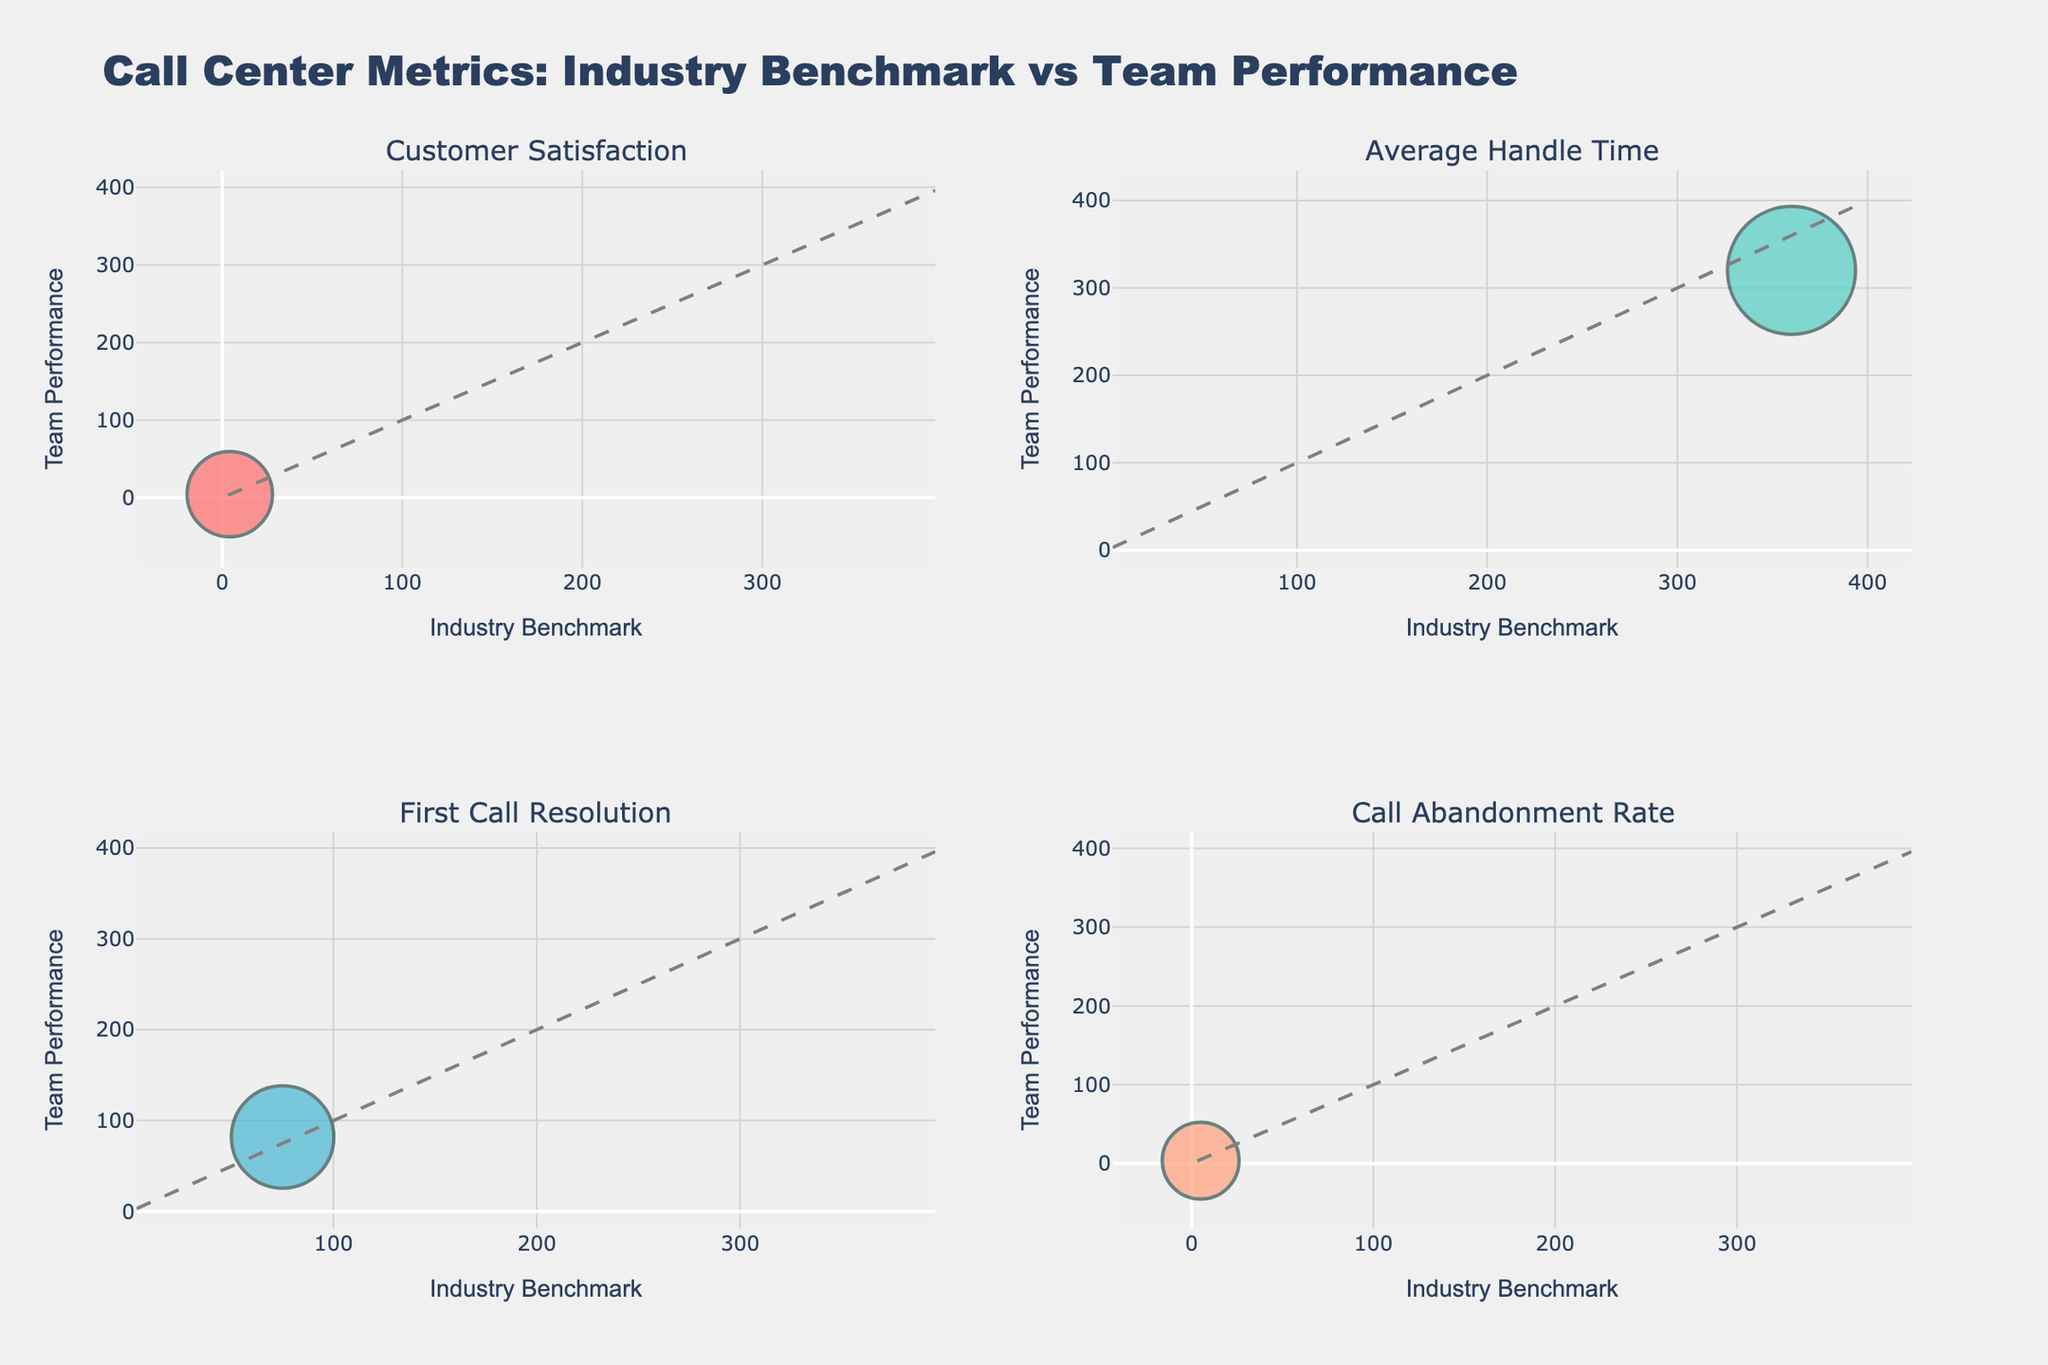What's the title of the figure? The title appears at the top of the figure. It reads "Call Center Metrics: Industry Benchmark vs Team Performance".
Answer: Call Center Metrics: Industry Benchmark vs Team Performance How many unique metrics are compared in the figure? There are four subplots, each representing a different metric: Customer Satisfaction, Average Handle Time, First Call Resolution, and Call Abandonment Rate.
Answer: 4 Which metric shows the largest bubble (indicating the highest call volume)? The size of the bubbles is proportional to the call volume. By comparing bubble sizes, we see that "Agent Utilization" has the largest bubble, indicating the highest call volume.
Answer: Agent Utilization Is the team performance for Average Handle Time better or worse than the industry benchmark? The team's performance should be compared to the industry benchmark in the "Average Handle Time" subplot, where a lower value is better because it means shorter call handling times. The team's average handle time is 320 seconds, which is better than the industry benchmark of 360 seconds.
Answer: Better Which metric shows both higher team performance and higher industry benchmark than the other metrics? By examining the plot, we see that "Quality Assurance Score" and "Net Promoter Score" both have higher values for both team performance and industry benchmark compared to other metrics.
Answer: Quality Assurance Score and Net Promoter Score What is the difference between the team's performance and the industry benchmark for First Call Resolution? The team's performance for First Call Resolution is 82, and the industry benchmark is 75. The difference is calculated as 82 - 75 = 7.
Answer: 7 How does the team’s performance for Call Abandonment Rate compare to the industry benchmark, and what does this indicate? In the "Call Abandonment Rate" subplot, the team's performance is 3.5%, which is lower than the industry benchmark of 5%. A lower abandonment rate indicates better performance, as fewer customers are hanging up before their issues are addressed.
Answer: Better What does the position of a bubble above the diagonal line indicate? A bubble above the diagonal line means the team performance is better than the industry benchmark for that metric. This comparison is visually represented by the position relative to the diagonal line.
Answer: Team performance better Which metric shows one of the smallest deviations from the industry benchmark? By observing the plots, "Average Speed of Answer" subplot shows a very small deviation, where the team's performance (25 seconds) is close to the industry benchmark (30 seconds).
Answer: Average Speed of Answer What can be inferred if a bubble is located on the diagonal line? If a bubble is located on the diagonal line, it indicates that the team performance is equal to the industry benchmark for that metric.
Answer: Team performance equal 